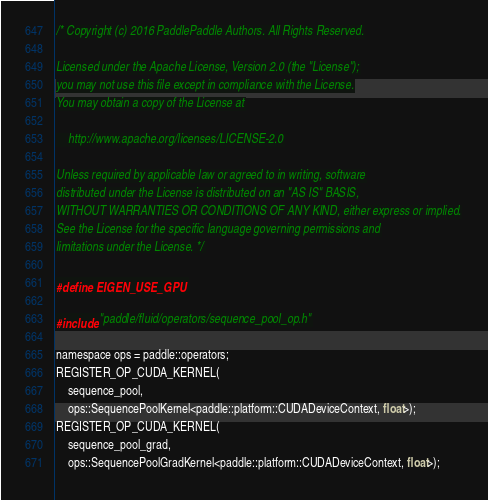<code> <loc_0><loc_0><loc_500><loc_500><_Cuda_>/* Copyright (c) 2016 PaddlePaddle Authors. All Rights Reserved.

Licensed under the Apache License, Version 2.0 (the "License");
you may not use this file except in compliance with the License.
You may obtain a copy of the License at

    http://www.apache.org/licenses/LICENSE-2.0

Unless required by applicable law or agreed to in writing, software
distributed under the License is distributed on an "AS IS" BASIS,
WITHOUT WARRANTIES OR CONDITIONS OF ANY KIND, either express or implied.
See the License for the specific language governing permissions and
limitations under the License. */

#define EIGEN_USE_GPU

#include "paddle/fluid/operators/sequence_pool_op.h"

namespace ops = paddle::operators;
REGISTER_OP_CUDA_KERNEL(
    sequence_pool,
    ops::SequencePoolKernel<paddle::platform::CUDADeviceContext, float>);
REGISTER_OP_CUDA_KERNEL(
    sequence_pool_grad,
    ops::SequencePoolGradKernel<paddle::platform::CUDADeviceContext, float>);
</code> 